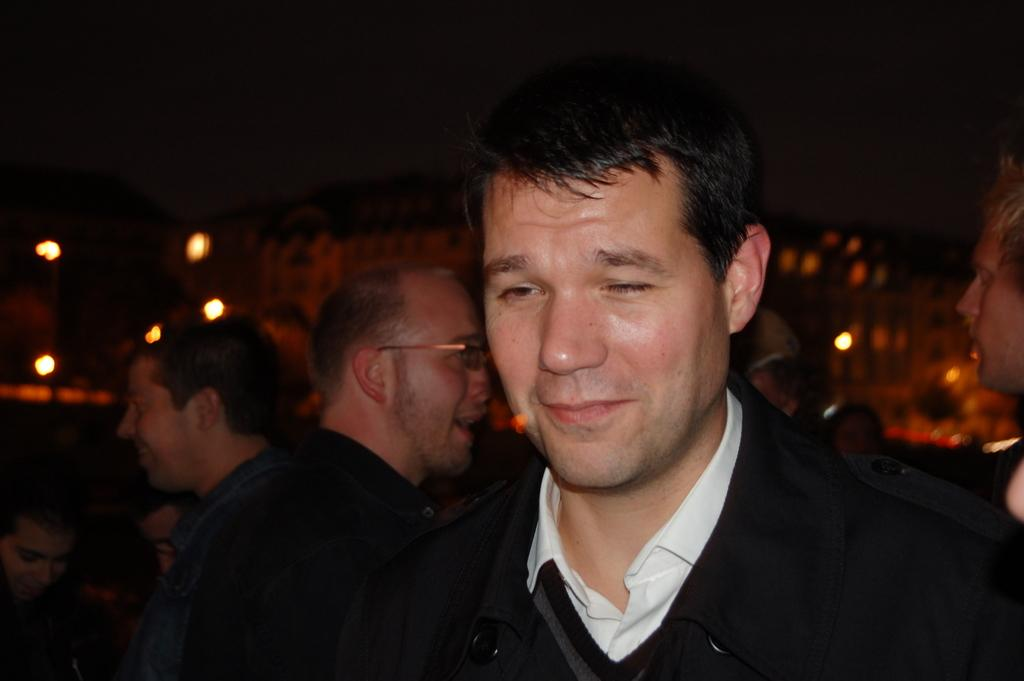Who or what is present in the image? There are people and buildings in the image. What else can be seen in the image? There are lights in the image. How would you describe the background of the image? The background of the image is blurred. What type of power does the banana provide in the image? There is no banana present in the image, so it cannot provide any power. 